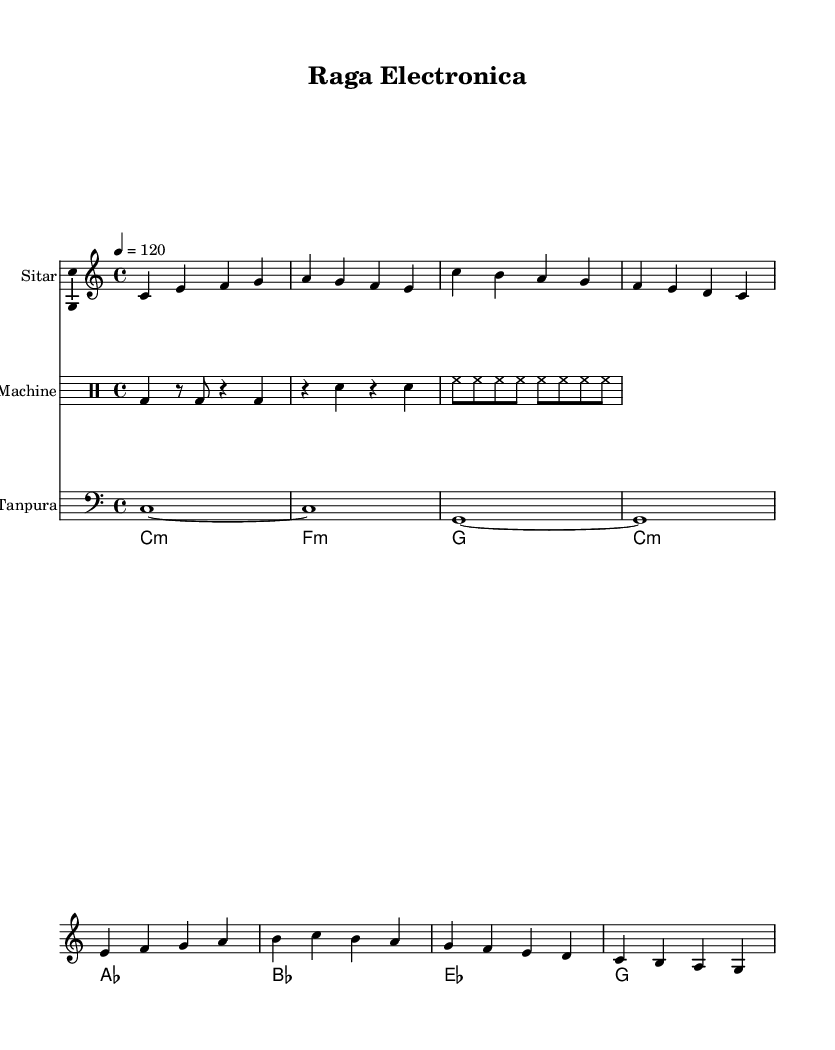What key signature is used in this score? The key signature is indicated as C major in the global settings at the beginning of the code, which represents no sharps or flats.
Answer: C major What is the time signature of the music? The time signature is shown as 4/4 in the global settings, which means four beats per measure and a quarter note gets one beat.
Answer: 4/4 What is the tempo marking for this piece? The tempo marking indicates a tempo of 120 beats per minute, specified by "tempo 4 = 120" in the global section.
Answer: 120 How many instruments are represented in the score? There are four distinct staves for different instruments: Sitar, Drum Machine, Tanpura, and Synth, as seen from the score layout.
Answer: Four What type of music does this piece represent? The key elements from the instruments (Sitar, Tanpura) and the blending with modern electronic sounds (Drum Machine, Synth) indicate it is a fusion of traditional Indian classical with electronic music.
Answer: Fusion How is the drum beat structured in this piece? The drum machine part alternates between bass drum (bd), snare (sn), and hi-hat (hh) with various rhythmic patterns across the measures, providing a modern beat structure.
Answer: Alternating What is the role of the Tanpura in this arrangement? The Tanpura provides a drone effect in the lower register, maintaining a constant pitch foundation throughout the piece, which is typical for classical Indian music.
Answer: Drone effect 